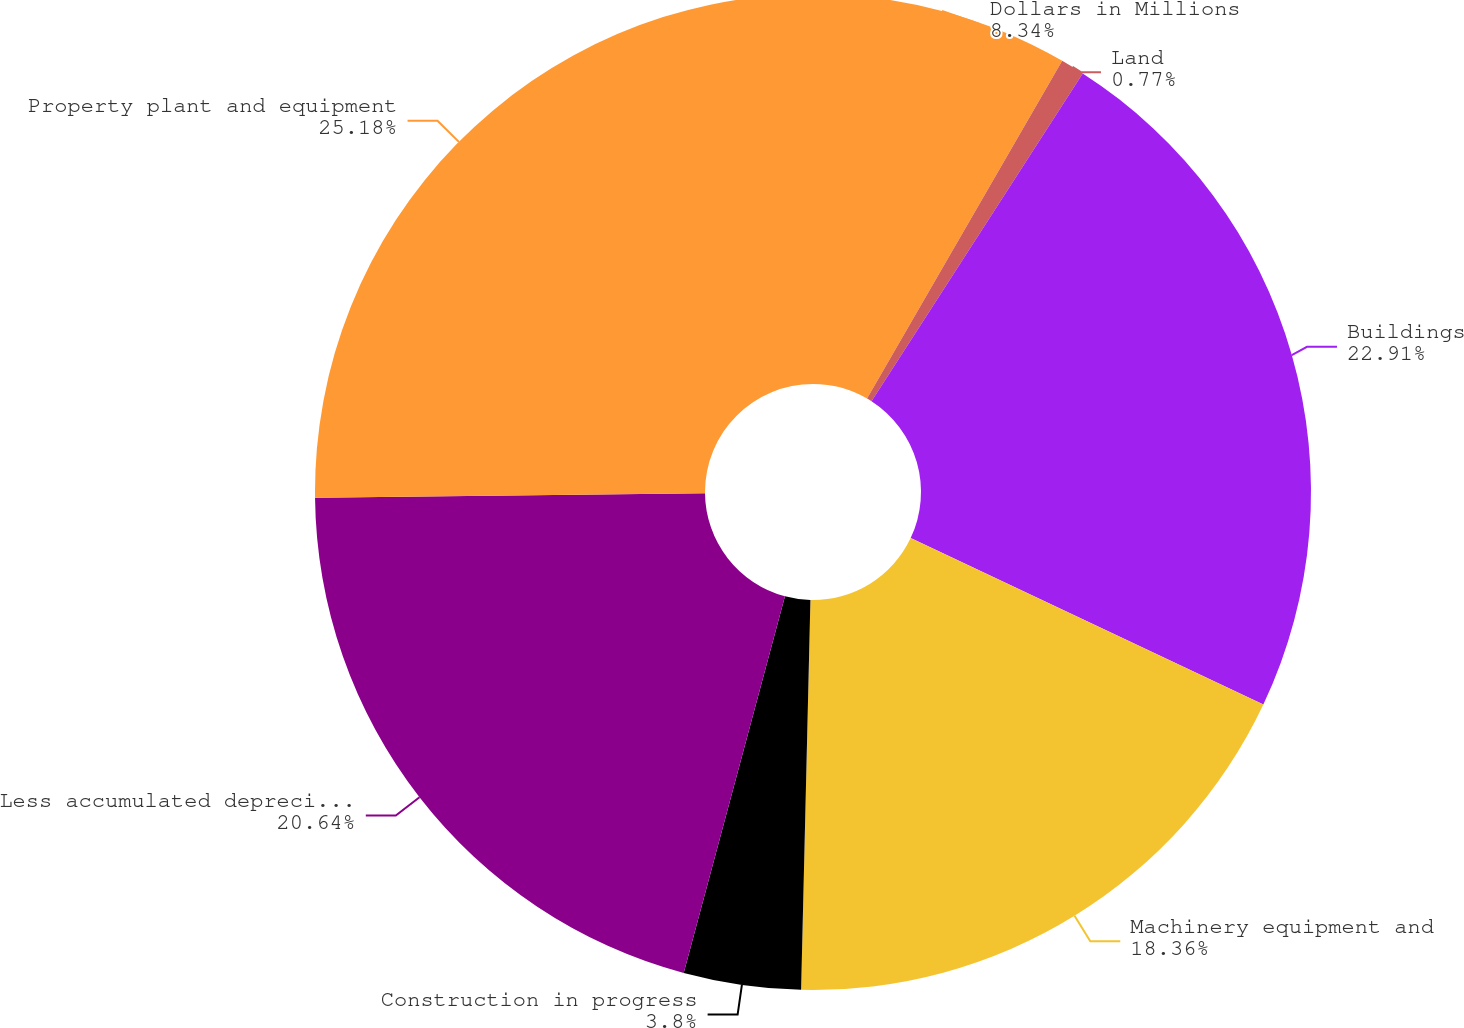Convert chart. <chart><loc_0><loc_0><loc_500><loc_500><pie_chart><fcel>Dollars in Millions<fcel>Land<fcel>Buildings<fcel>Machinery equipment and<fcel>Construction in progress<fcel>Less accumulated depreciation<fcel>Property plant and equipment<nl><fcel>8.34%<fcel>0.77%<fcel>22.91%<fcel>18.36%<fcel>3.8%<fcel>20.64%<fcel>25.18%<nl></chart> 